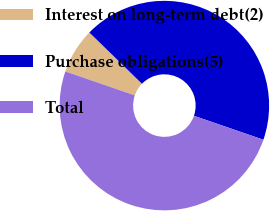Convert chart. <chart><loc_0><loc_0><loc_500><loc_500><pie_chart><fcel>Interest on long-term debt(2)<fcel>Purchase obligations(5)<fcel>Total<nl><fcel>7.01%<fcel>42.99%<fcel>50.0%<nl></chart> 